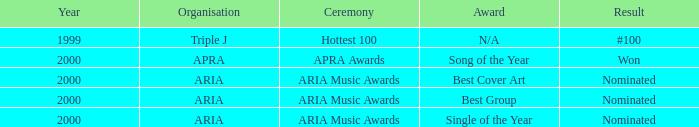What were the conclusions reached before the year 2000? #100. 